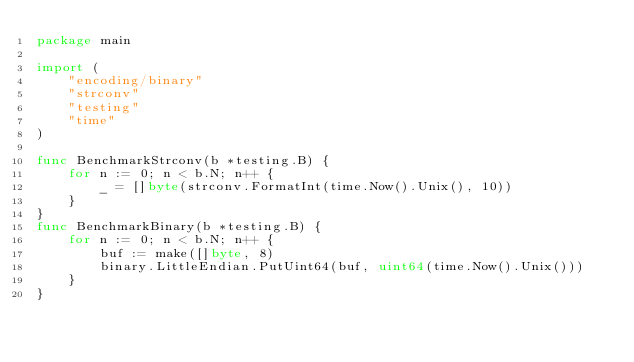Convert code to text. <code><loc_0><loc_0><loc_500><loc_500><_Go_>package main

import (
	"encoding/binary"
	"strconv"
	"testing"
	"time"
)

func BenchmarkStrconv(b *testing.B) {
	for n := 0; n < b.N; n++ {
		_ = []byte(strconv.FormatInt(time.Now().Unix(), 10))
	}
}
func BenchmarkBinary(b *testing.B) {
	for n := 0; n < b.N; n++ {
		buf := make([]byte, 8)
		binary.LittleEndian.PutUint64(buf, uint64(time.Now().Unix()))
	}
}
</code> 